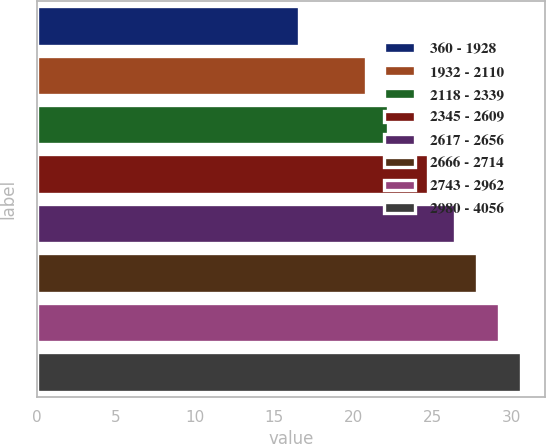<chart> <loc_0><loc_0><loc_500><loc_500><bar_chart><fcel>360 - 1928<fcel>1932 - 2110<fcel>2118 - 2339<fcel>2345 - 2609<fcel>2617 - 2656<fcel>2666 - 2714<fcel>2743 - 2962<fcel>2980 - 4056<nl><fcel>16.58<fcel>20.82<fcel>22.22<fcel>24.71<fcel>26.4<fcel>27.8<fcel>29.2<fcel>30.6<nl></chart> 